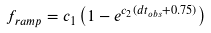<formula> <loc_0><loc_0><loc_500><loc_500>f _ { r a m p } = c _ { 1 } \left ( 1 - e ^ { c _ { 2 } ( d t _ { o b s } + 0 . 7 5 ) } \right )</formula> 